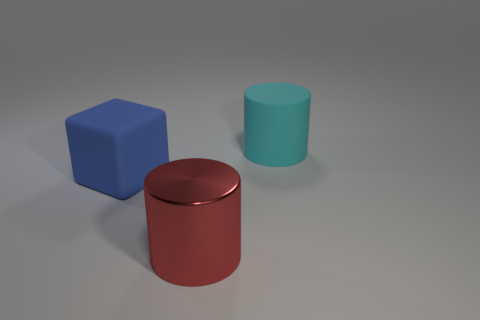Is there anything else that has the same material as the large red cylinder?
Your response must be concise. No. How many rubber things are both behind the large matte block and in front of the big cyan cylinder?
Your answer should be compact. 0. The large object that is to the left of the object in front of the blue rubber cube is what color?
Give a very brief answer. Blue. Are there the same number of big red metallic cylinders that are right of the blue thing and big balls?
Offer a very short reply. No. There is a large matte object that is on the left side of the matte cylinder on the right side of the blue matte object; what number of large objects are in front of it?
Offer a terse response. 1. What is the color of the big cylinder in front of the cube?
Make the answer very short. Red. What material is the big thing that is behind the big red cylinder and in front of the big cyan thing?
Provide a short and direct response. Rubber. There is a cylinder that is in front of the large cyan cylinder; how many large cyan cylinders are in front of it?
Your answer should be very brief. 0. What is the shape of the big red metal thing?
Provide a short and direct response. Cylinder. The big thing that is made of the same material as the blue cube is what shape?
Provide a succinct answer. Cylinder. 